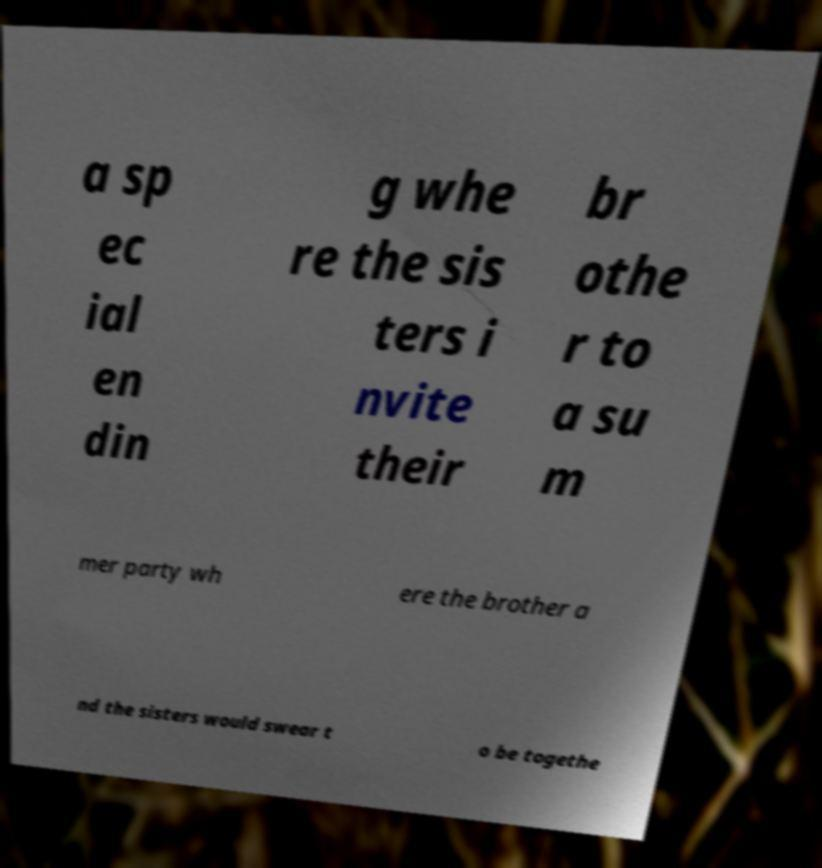Please read and relay the text visible in this image. What does it say? a sp ec ial en din g whe re the sis ters i nvite their br othe r to a su m mer party wh ere the brother a nd the sisters would swear t o be togethe 